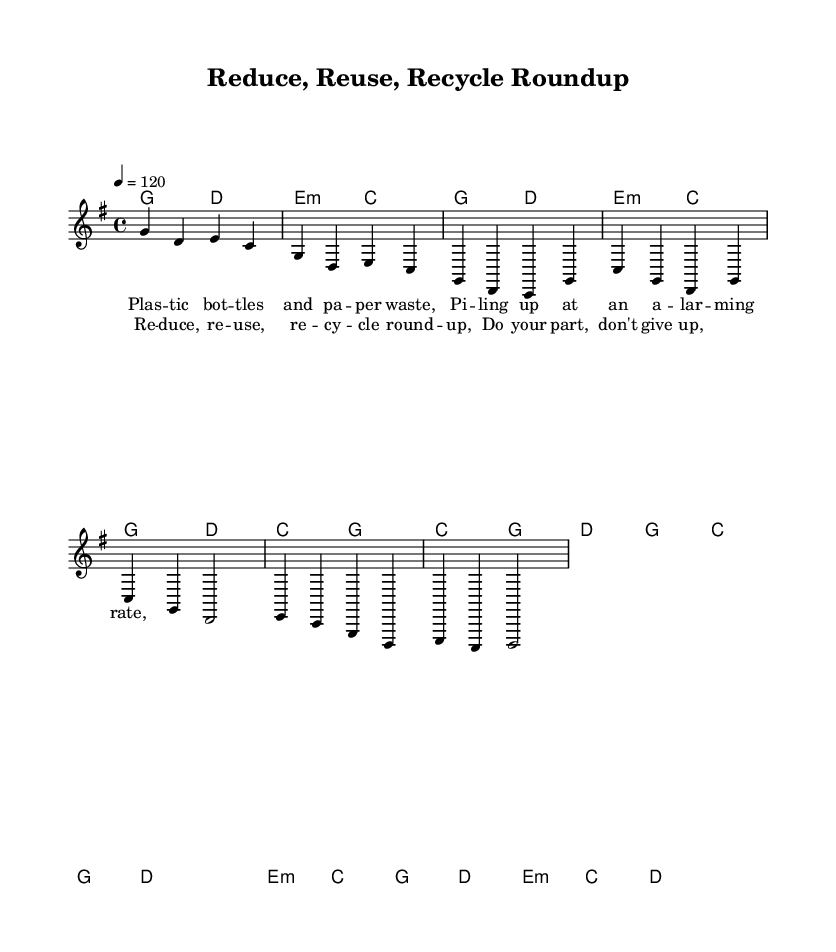What is the time signature of this music? The time signature shown in the music sheet is 4/4, which indicates there are four beats per measure and the quarter note receives one beat.
Answer: 4/4 What is the key signature of this music? The key signature provided in the music is G major, which contains one sharp (F#). This is indicated at the beginning of the staff.
Answer: G major What is the tempo marking of this piece? The tempo marking is set at quarter note = 120, indicating that there are 120 beats in a minute, thus establishing a lively pace for the song.
Answer: 120 How many measures are there in the chorus? The chorus consists of 4 measures from what is displayed in the music sheet, as it has a clear section marked for the chorus lyrics.
Answer: 4 What is the chord for the bridge section? The bridge section utilizes the chords E minor and C, which are indicated in the harmony section of the music sheet.
Answer: E minor, C What is the main theme of the lyrics in the verse? The lyrics focus on themes of waste and environmental issues, particularly highlighting plastic waste, as evidenced in the provided lyric segment.
Answer: Waste What genre does this piece belong to? The piece is classified as Country Rock, indicated by its stylistic elements and instrumentation typical of the genre, combining country music themes with rock rhythms.
Answer: Country Rock 